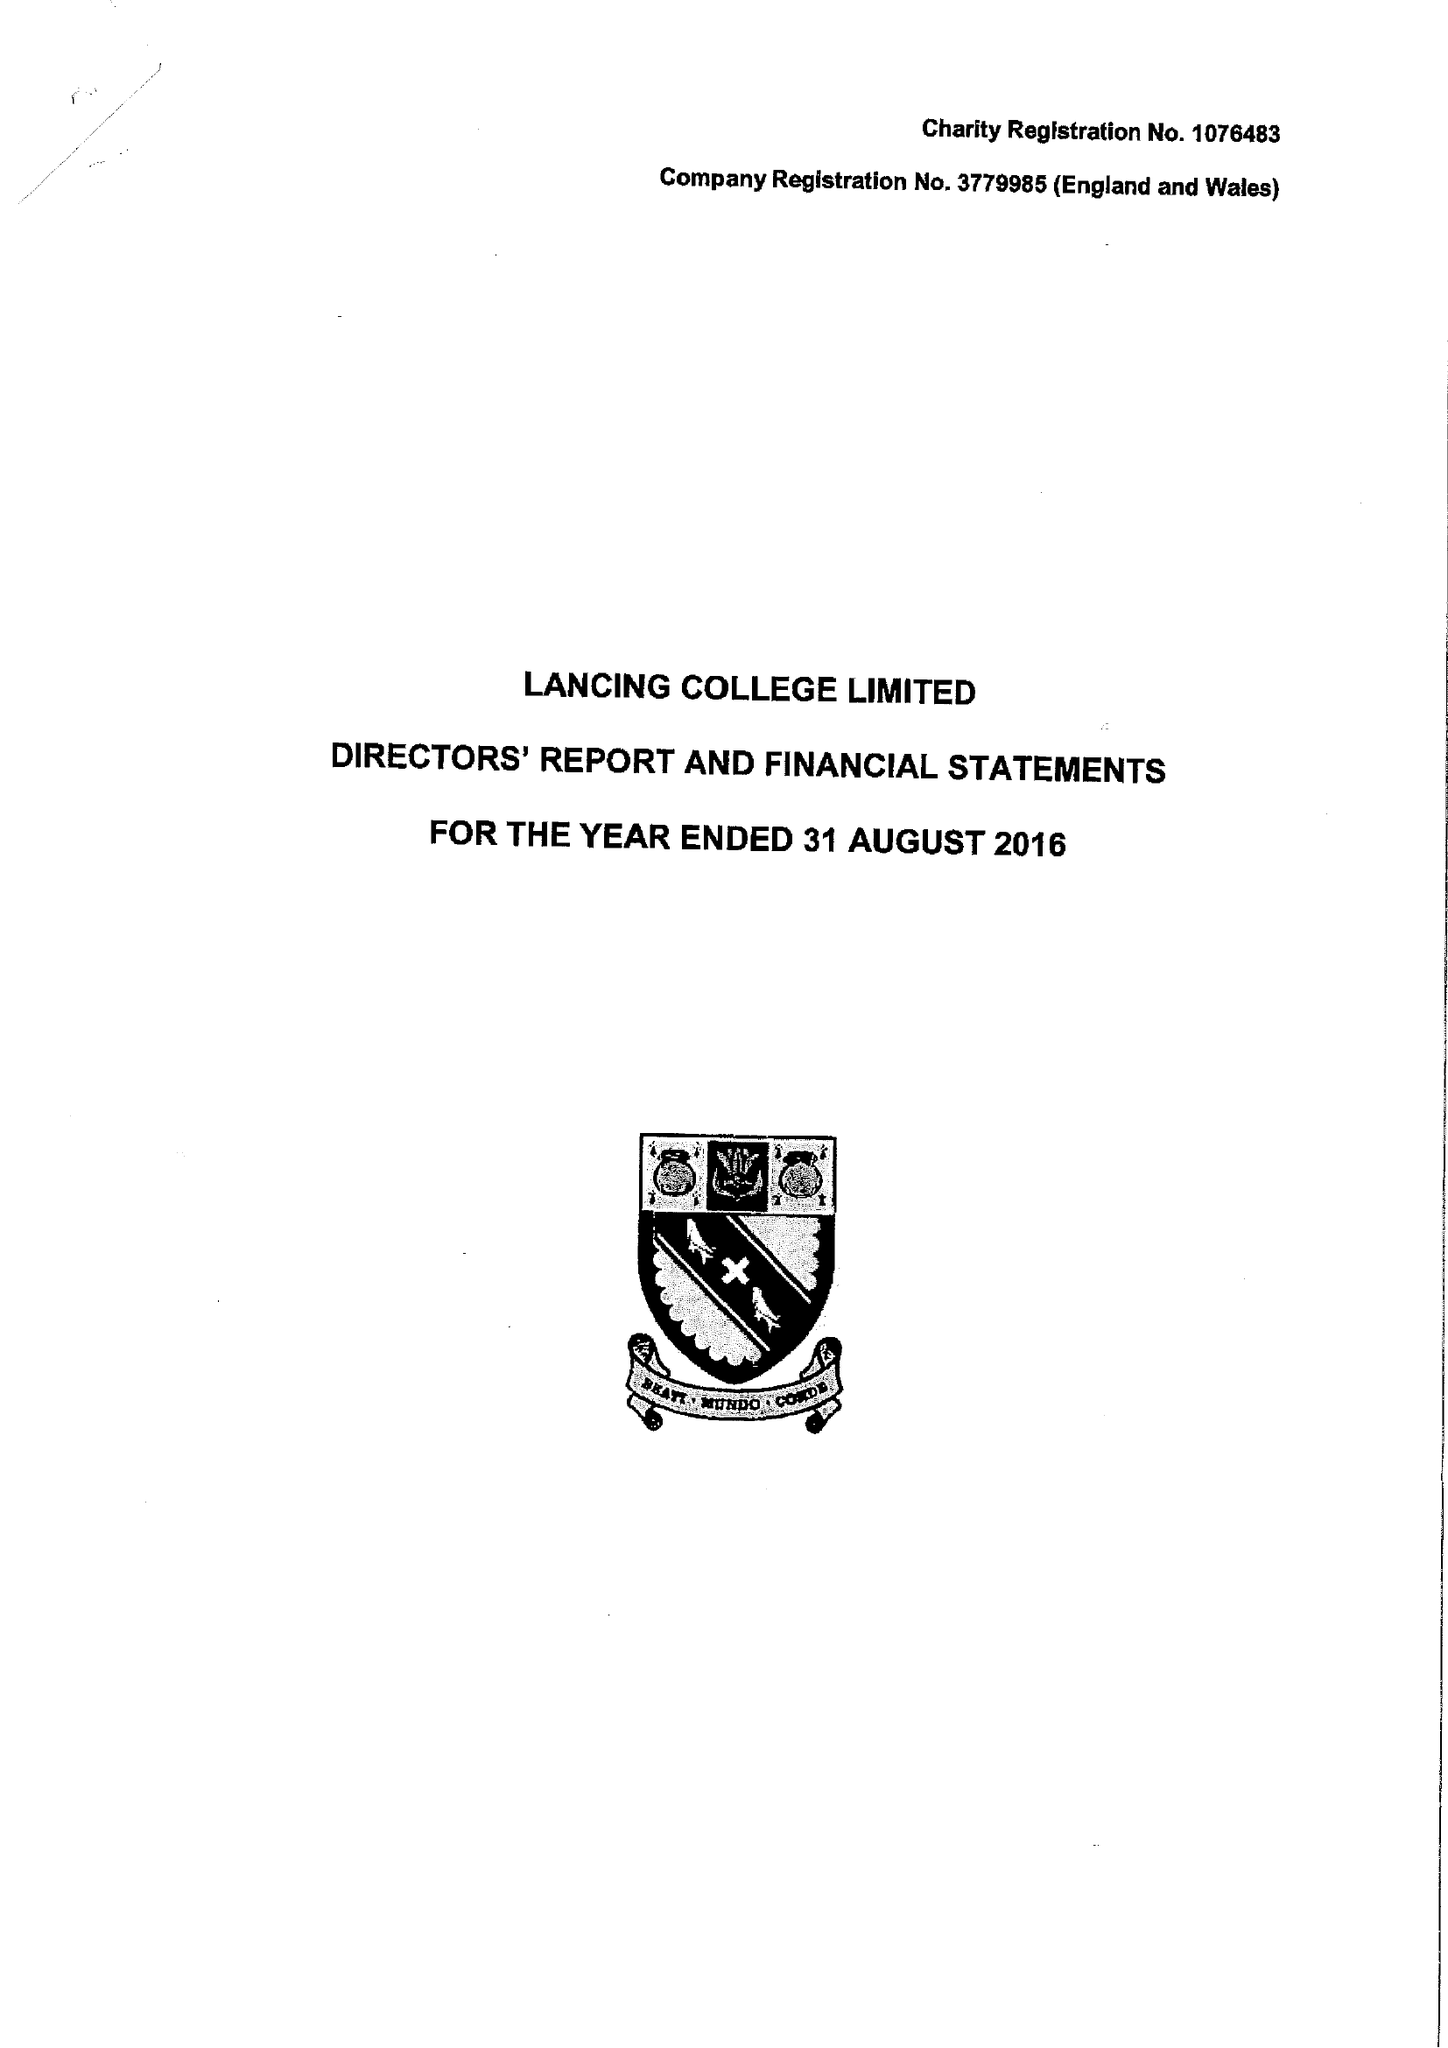What is the value for the address__postcode?
Answer the question using a single word or phrase. BN15 0RW 